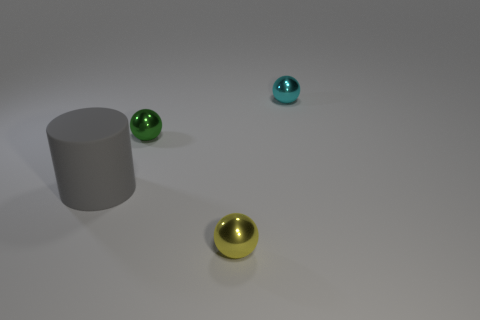The matte thing has what color?
Keep it short and to the point. Gray. The object in front of the gray matte object is what color?
Provide a short and direct response. Yellow. There is a sphere to the right of the yellow object; what number of metal spheres are to the left of it?
Keep it short and to the point. 2. There is a cylinder; is it the same size as the metal ball in front of the gray rubber object?
Ensure brevity in your answer.  No. Are there any cyan things that have the same size as the green sphere?
Ensure brevity in your answer.  Yes. How many things are either small red matte blocks or shiny things?
Offer a very short reply. 3. There is a shiny object in front of the gray object; is it the same size as the shiny ball behind the green sphere?
Keep it short and to the point. Yes. Is there another cyan object that has the same shape as the big rubber object?
Provide a succinct answer. No. Are there fewer rubber objects right of the small yellow shiny ball than green spheres?
Offer a very short reply. Yes. Is the shape of the rubber object the same as the green object?
Provide a short and direct response. No. 